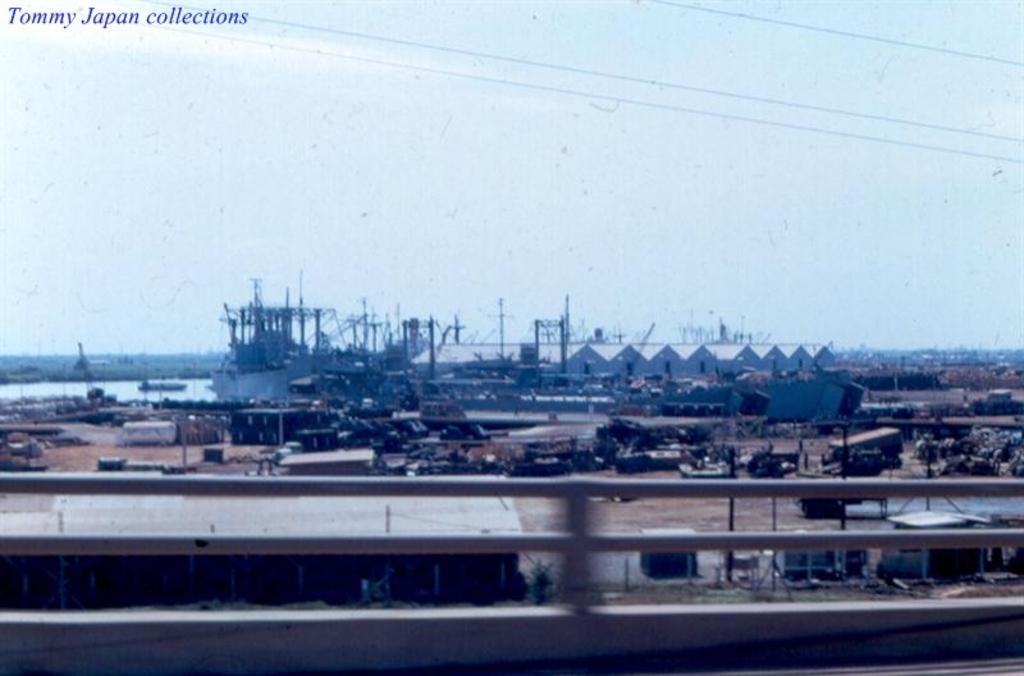What type of location is depicted in the image? The image is of a city. What specific feature can be seen in the city? There is a shipyard in the image. What is on the water in the image? There is a boat on the water in the image. What can be seen in the background of the image? The sky is visible in the background of the image. Where is the cobweb located in the image? There is no cobweb present in the image. What type of watch is visible on the boat in the image? There is no watch visible on the boat in the image. 